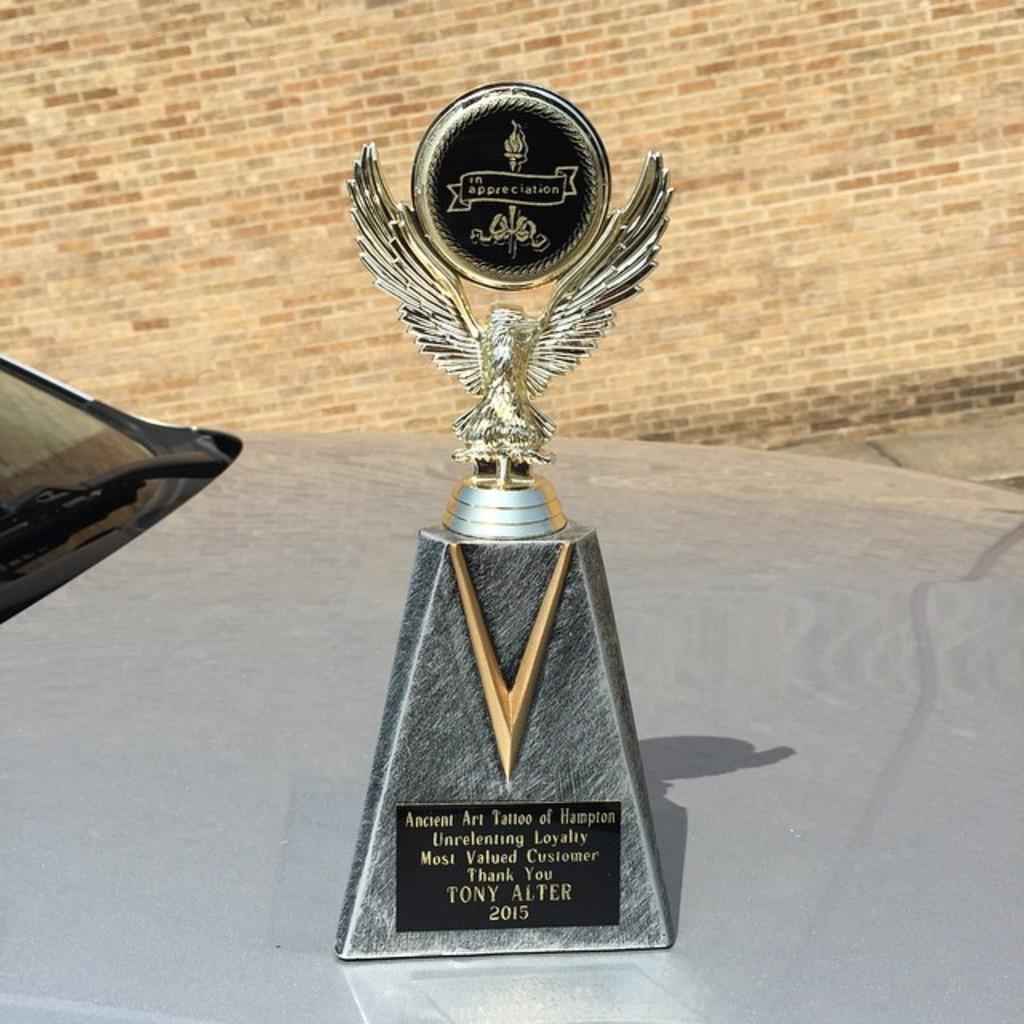Provide a one-sentence caption for the provided image. A trophy that is awarded to Tony Alter. 